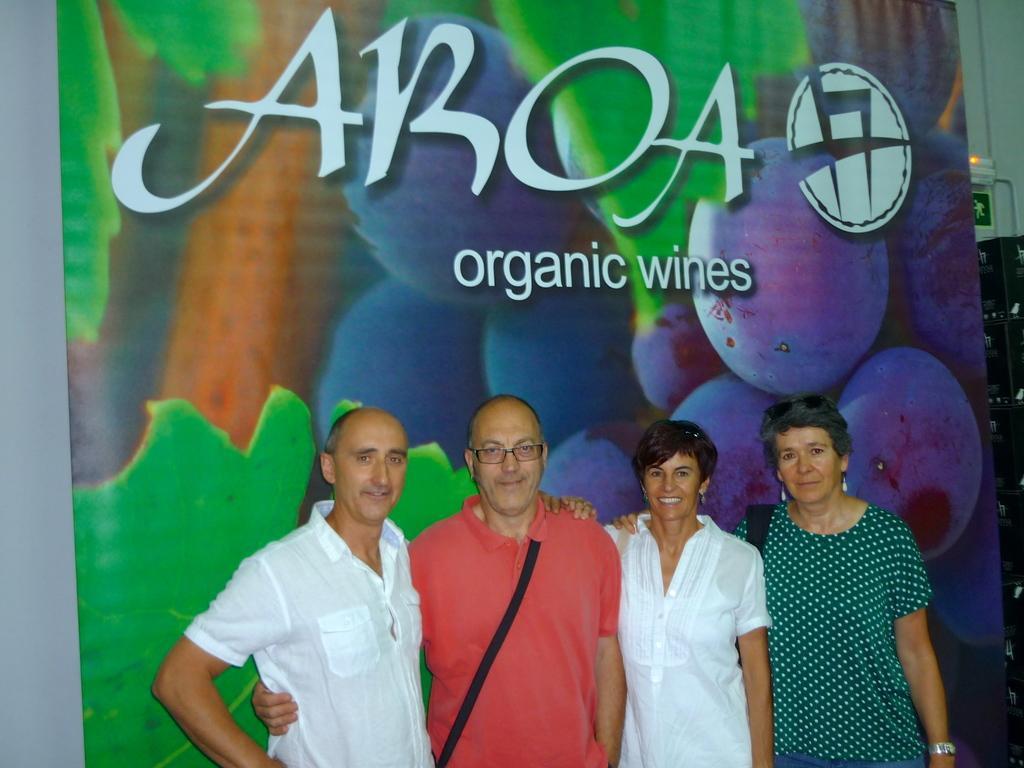Can you describe this image briefly? On the left and right side there are two men and two women standing and among them a man is carrying a bag on his shoulder. In the background there is a hoarding,wall,sky and some other objects. 